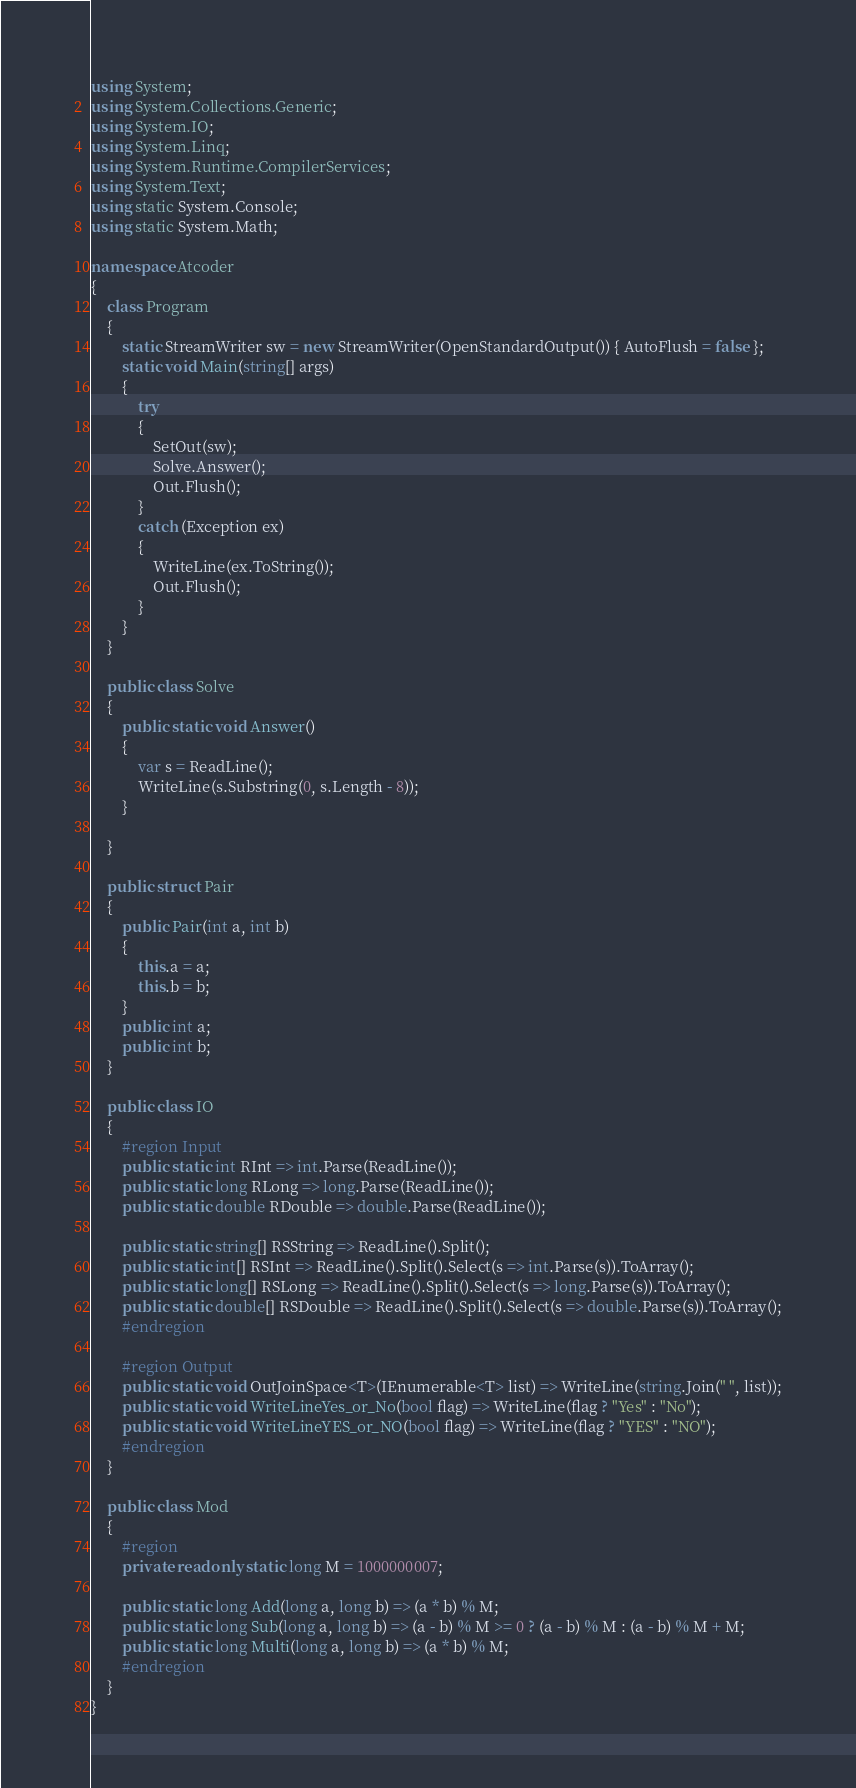Convert code to text. <code><loc_0><loc_0><loc_500><loc_500><_C#_>using System;
using System.Collections.Generic;
using System.IO;
using System.Linq;
using System.Runtime.CompilerServices;
using System.Text;
using static System.Console;
using static System.Math;

namespace Atcoder
{
    class Program
    {
        static StreamWriter sw = new StreamWriter(OpenStandardOutput()) { AutoFlush = false };
        static void Main(string[] args)
        {
            try
            {
                SetOut(sw);
                Solve.Answer();
                Out.Flush();
            }
            catch (Exception ex)
            {
                WriteLine(ex.ToString());
                Out.Flush();
            }
        }
    }

    public class Solve
    {
        public static void Answer()
        {
            var s = ReadLine();
            WriteLine(s.Substring(0, s.Length - 8));
        }

    }

    public struct Pair
    {
        public Pair(int a, int b)
        {
            this.a = a;
            this.b = b;
        }
        public int a;
        public int b;
    }

    public class IO
    {
        #region Input
        public static int RInt => int.Parse(ReadLine());
        public static long RLong => long.Parse(ReadLine());
        public static double RDouble => double.Parse(ReadLine());

        public static string[] RSString => ReadLine().Split();
        public static int[] RSInt => ReadLine().Split().Select(s => int.Parse(s)).ToArray();
        public static long[] RSLong => ReadLine().Split().Select(s => long.Parse(s)).ToArray();
        public static double[] RSDouble => ReadLine().Split().Select(s => double.Parse(s)).ToArray();
        #endregion

        #region Output
        public static void OutJoinSpace<T>(IEnumerable<T> list) => WriteLine(string.Join(" ", list));
        public static void WriteLineYes_or_No(bool flag) => WriteLine(flag ? "Yes" : "No");
        public static void WriteLineYES_or_NO(bool flag) => WriteLine(flag ? "YES" : "NO");
        #endregion
    }

    public class Mod
    {
        #region
        private readonly static long M = 1000000007;

        public static long Add(long a, long b) => (a * b) % M;
        public static long Sub(long a, long b) => (a - b) % M >= 0 ? (a - b) % M : (a - b) % M + M;
        public static long Multi(long a, long b) => (a * b) % M;
        #endregion
    }
}</code> 